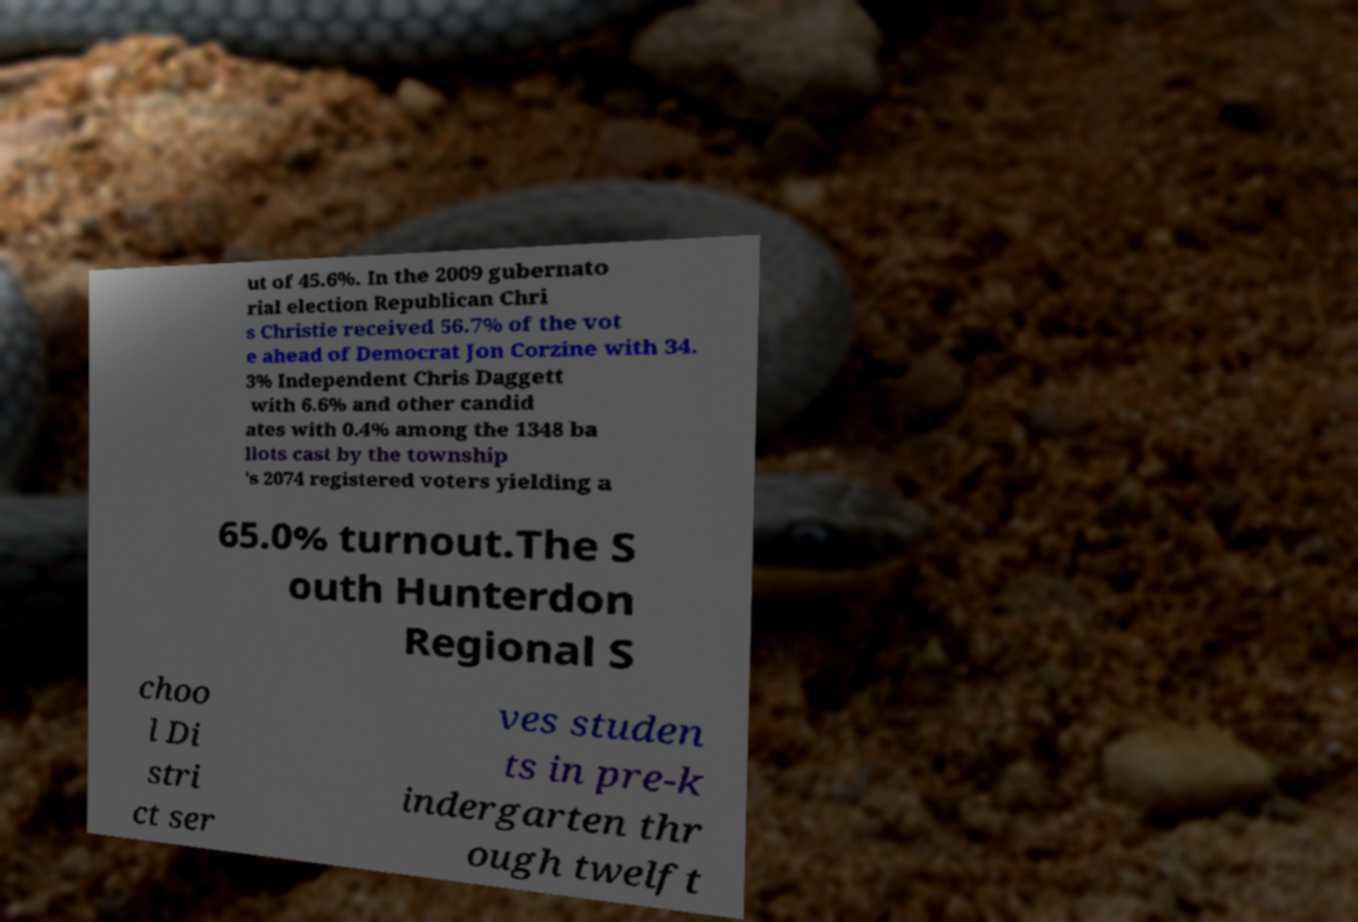Could you assist in decoding the text presented in this image and type it out clearly? ut of 45.6%. In the 2009 gubernato rial election Republican Chri s Christie received 56.7% of the vot e ahead of Democrat Jon Corzine with 34. 3% Independent Chris Daggett with 6.6% and other candid ates with 0.4% among the 1348 ba llots cast by the township 's 2074 registered voters yielding a 65.0% turnout.The S outh Hunterdon Regional S choo l Di stri ct ser ves studen ts in pre-k indergarten thr ough twelft 